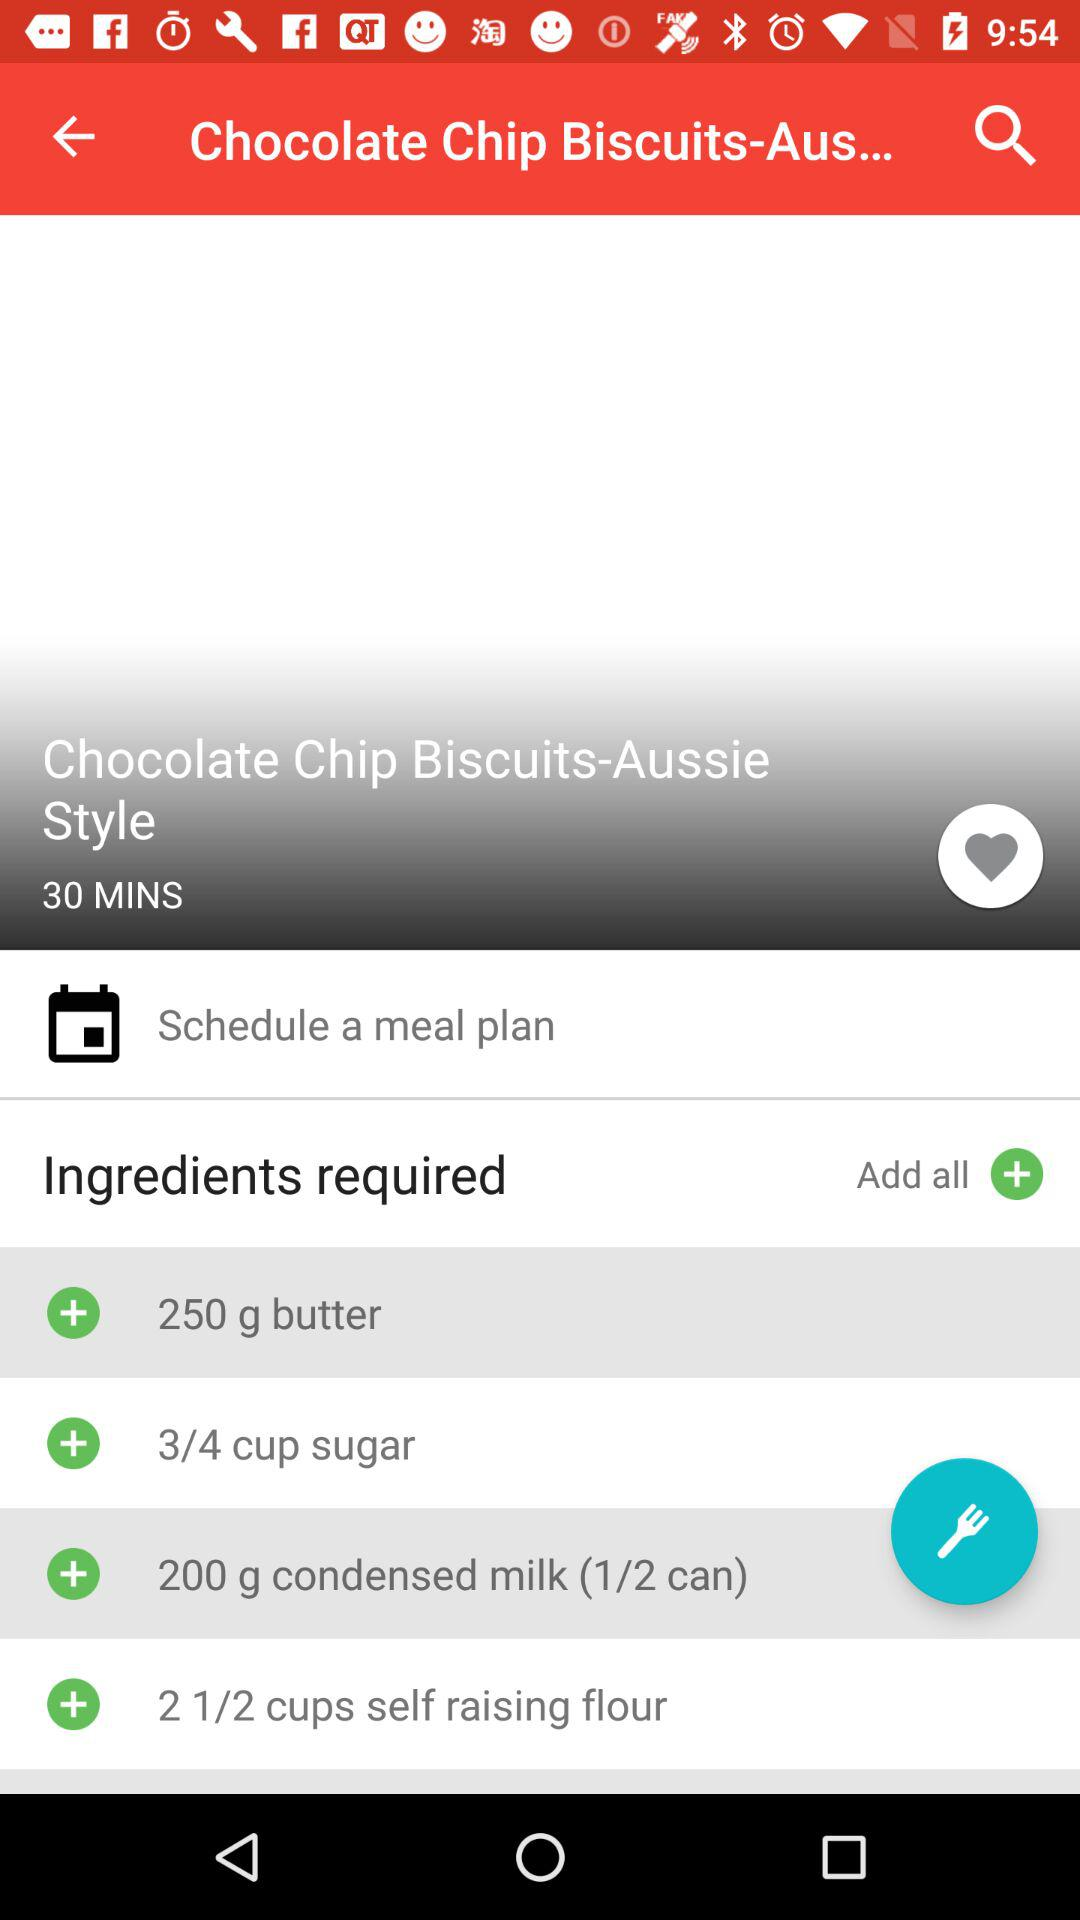What is the name of the recipe? The name of the recipe is "Chocolate Chip Biscuits-Aussie Style". 